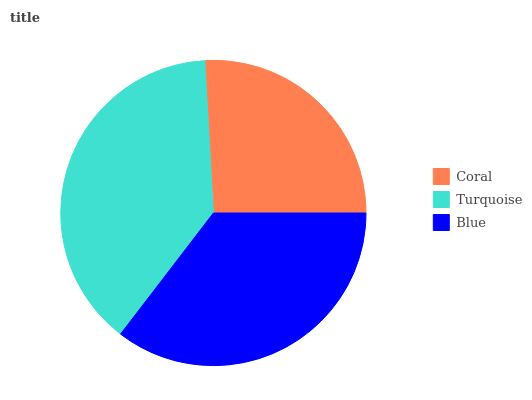Is Coral the minimum?
Answer yes or no. Yes. Is Turquoise the maximum?
Answer yes or no. Yes. Is Blue the minimum?
Answer yes or no. No. Is Blue the maximum?
Answer yes or no. No. Is Turquoise greater than Blue?
Answer yes or no. Yes. Is Blue less than Turquoise?
Answer yes or no. Yes. Is Blue greater than Turquoise?
Answer yes or no. No. Is Turquoise less than Blue?
Answer yes or no. No. Is Blue the high median?
Answer yes or no. Yes. Is Blue the low median?
Answer yes or no. Yes. Is Turquoise the high median?
Answer yes or no. No. Is Turquoise the low median?
Answer yes or no. No. 